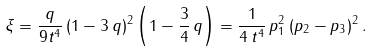<formula> <loc_0><loc_0><loc_500><loc_500>\xi = \frac { q } { 9 t ^ { 4 } } \, ( 1 - 3 \, q ) ^ { 2 } \left ( 1 - \frac { 3 } { 4 } \, q \right ) = \frac { 1 } { 4 \, t ^ { 4 } } \, p _ { 1 } ^ { 2 } \, ( p _ { 2 } - p _ { 3 } ) ^ { 2 } \, .</formula> 